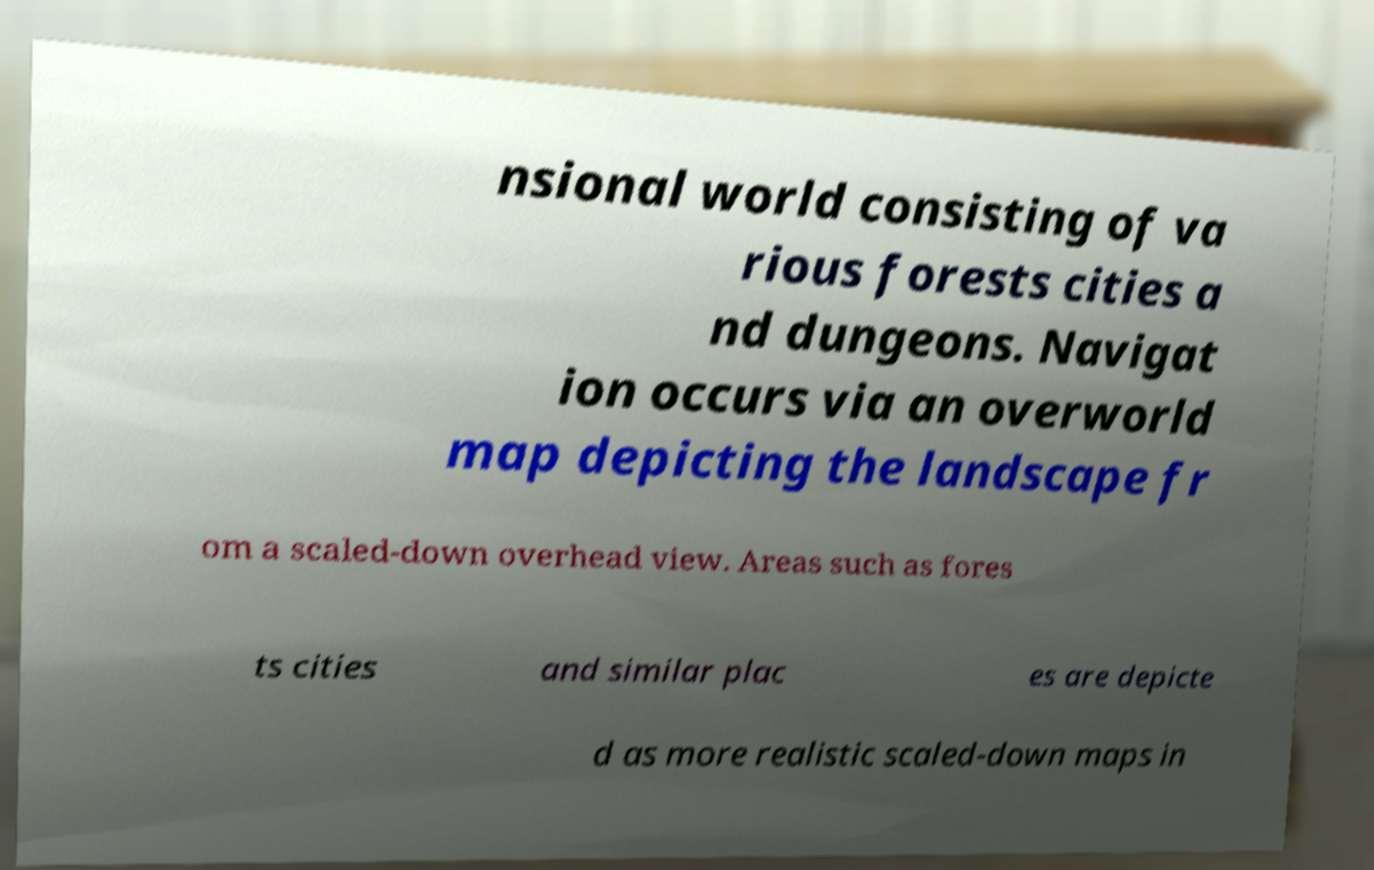Can you read and provide the text displayed in the image?This photo seems to have some interesting text. Can you extract and type it out for me? nsional world consisting of va rious forests cities a nd dungeons. Navigat ion occurs via an overworld map depicting the landscape fr om a scaled-down overhead view. Areas such as fores ts cities and similar plac es are depicte d as more realistic scaled-down maps in 